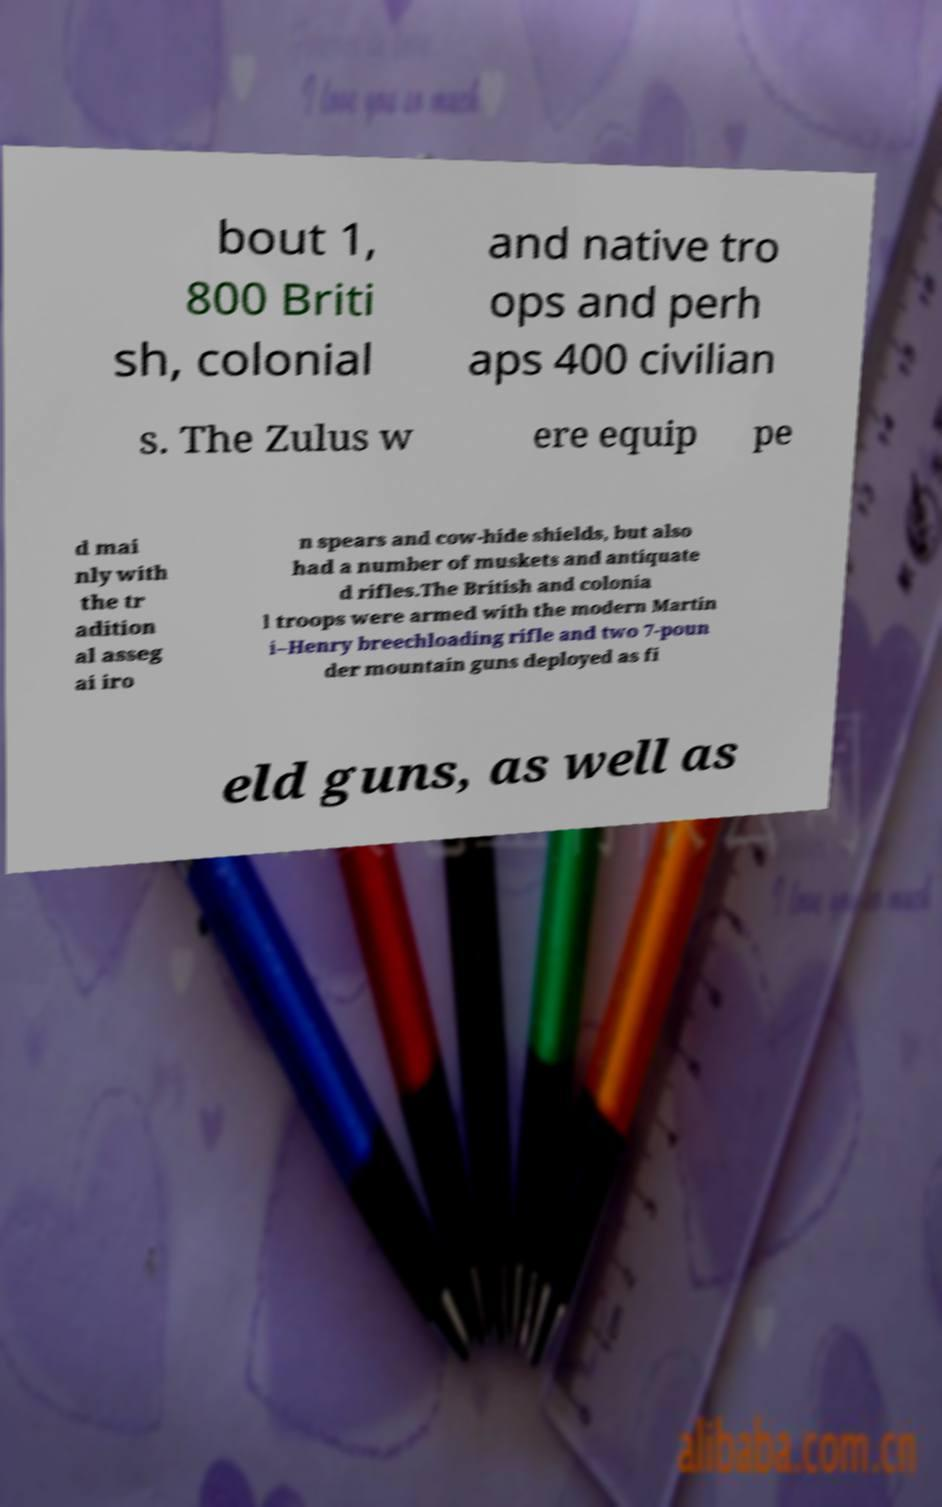Can you read and provide the text displayed in the image?This photo seems to have some interesting text. Can you extract and type it out for me? bout 1, 800 Briti sh, colonial and native tro ops and perh aps 400 civilian s. The Zulus w ere equip pe d mai nly with the tr adition al asseg ai iro n spears and cow-hide shields, but also had a number of muskets and antiquate d rifles.The British and colonia l troops were armed with the modern Martin i–Henry breechloading rifle and two 7-poun der mountain guns deployed as fi eld guns, as well as 